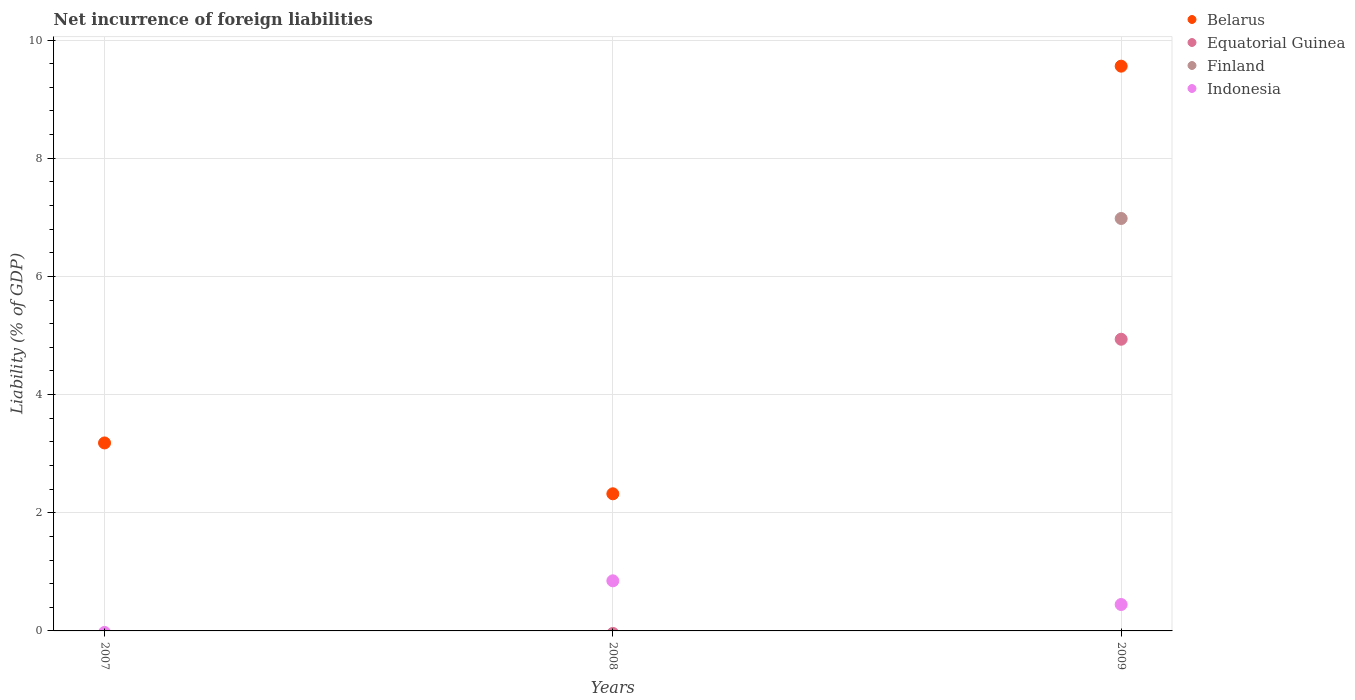How many different coloured dotlines are there?
Make the answer very short. 4. Across all years, what is the maximum net incurrence of foreign liabilities in Finland?
Provide a succinct answer. 6.98. Across all years, what is the minimum net incurrence of foreign liabilities in Finland?
Make the answer very short. 0. What is the total net incurrence of foreign liabilities in Belarus in the graph?
Your response must be concise. 15.06. What is the difference between the net incurrence of foreign liabilities in Indonesia in 2008 and that in 2009?
Your response must be concise. 0.4. What is the difference between the net incurrence of foreign liabilities in Indonesia in 2008 and the net incurrence of foreign liabilities in Equatorial Guinea in 2007?
Give a very brief answer. 0.85. What is the average net incurrence of foreign liabilities in Finland per year?
Make the answer very short. 2.33. In the year 2009, what is the difference between the net incurrence of foreign liabilities in Equatorial Guinea and net incurrence of foreign liabilities in Finland?
Ensure brevity in your answer.  -2.04. In how many years, is the net incurrence of foreign liabilities in Indonesia greater than 9.2 %?
Make the answer very short. 0. What is the ratio of the net incurrence of foreign liabilities in Indonesia in 2008 to that in 2009?
Give a very brief answer. 1.9. What is the difference between the highest and the lowest net incurrence of foreign liabilities in Belarus?
Your answer should be compact. 7.24. Is it the case that in every year, the sum of the net incurrence of foreign liabilities in Equatorial Guinea and net incurrence of foreign liabilities in Belarus  is greater than the net incurrence of foreign liabilities in Finland?
Keep it short and to the point. Yes. Is the net incurrence of foreign liabilities in Equatorial Guinea strictly greater than the net incurrence of foreign liabilities in Belarus over the years?
Make the answer very short. No. How many years are there in the graph?
Provide a succinct answer. 3. Are the values on the major ticks of Y-axis written in scientific E-notation?
Give a very brief answer. No. Does the graph contain grids?
Make the answer very short. Yes. How many legend labels are there?
Make the answer very short. 4. What is the title of the graph?
Provide a short and direct response. Net incurrence of foreign liabilities. Does "Middle East & North Africa (developing only)" appear as one of the legend labels in the graph?
Ensure brevity in your answer.  No. What is the label or title of the X-axis?
Offer a very short reply. Years. What is the label or title of the Y-axis?
Keep it short and to the point. Liability (% of GDP). What is the Liability (% of GDP) in Belarus in 2007?
Make the answer very short. 3.18. What is the Liability (% of GDP) in Equatorial Guinea in 2007?
Provide a short and direct response. 0. What is the Liability (% of GDP) of Finland in 2007?
Your response must be concise. 0. What is the Liability (% of GDP) in Belarus in 2008?
Keep it short and to the point. 2.32. What is the Liability (% of GDP) in Equatorial Guinea in 2008?
Give a very brief answer. 0. What is the Liability (% of GDP) of Finland in 2008?
Make the answer very short. 0. What is the Liability (% of GDP) of Indonesia in 2008?
Make the answer very short. 0.85. What is the Liability (% of GDP) of Belarus in 2009?
Your response must be concise. 9.56. What is the Liability (% of GDP) in Equatorial Guinea in 2009?
Offer a terse response. 4.94. What is the Liability (% of GDP) in Finland in 2009?
Give a very brief answer. 6.98. What is the Liability (% of GDP) of Indonesia in 2009?
Provide a succinct answer. 0.45. Across all years, what is the maximum Liability (% of GDP) of Belarus?
Provide a short and direct response. 9.56. Across all years, what is the maximum Liability (% of GDP) in Equatorial Guinea?
Keep it short and to the point. 4.94. Across all years, what is the maximum Liability (% of GDP) of Finland?
Your answer should be very brief. 6.98. Across all years, what is the maximum Liability (% of GDP) of Indonesia?
Your response must be concise. 0.85. Across all years, what is the minimum Liability (% of GDP) in Belarus?
Make the answer very short. 2.32. Across all years, what is the minimum Liability (% of GDP) in Indonesia?
Keep it short and to the point. 0. What is the total Liability (% of GDP) of Belarus in the graph?
Offer a very short reply. 15.06. What is the total Liability (% of GDP) in Equatorial Guinea in the graph?
Your answer should be very brief. 4.94. What is the total Liability (% of GDP) of Finland in the graph?
Your answer should be very brief. 6.98. What is the total Liability (% of GDP) of Indonesia in the graph?
Your answer should be very brief. 1.29. What is the difference between the Liability (% of GDP) in Belarus in 2007 and that in 2008?
Offer a very short reply. 0.86. What is the difference between the Liability (% of GDP) of Belarus in 2007 and that in 2009?
Your answer should be very brief. -6.38. What is the difference between the Liability (% of GDP) in Belarus in 2008 and that in 2009?
Keep it short and to the point. -7.24. What is the difference between the Liability (% of GDP) in Indonesia in 2008 and that in 2009?
Provide a succinct answer. 0.4. What is the difference between the Liability (% of GDP) of Belarus in 2007 and the Liability (% of GDP) of Indonesia in 2008?
Your answer should be compact. 2.33. What is the difference between the Liability (% of GDP) in Belarus in 2007 and the Liability (% of GDP) in Equatorial Guinea in 2009?
Provide a short and direct response. -1.76. What is the difference between the Liability (% of GDP) in Belarus in 2007 and the Liability (% of GDP) in Finland in 2009?
Provide a succinct answer. -3.8. What is the difference between the Liability (% of GDP) of Belarus in 2007 and the Liability (% of GDP) of Indonesia in 2009?
Your answer should be very brief. 2.73. What is the difference between the Liability (% of GDP) of Belarus in 2008 and the Liability (% of GDP) of Equatorial Guinea in 2009?
Offer a terse response. -2.62. What is the difference between the Liability (% of GDP) in Belarus in 2008 and the Liability (% of GDP) in Finland in 2009?
Your answer should be compact. -4.66. What is the difference between the Liability (% of GDP) in Belarus in 2008 and the Liability (% of GDP) in Indonesia in 2009?
Your answer should be compact. 1.87. What is the average Liability (% of GDP) of Belarus per year?
Your response must be concise. 5.02. What is the average Liability (% of GDP) of Equatorial Guinea per year?
Ensure brevity in your answer.  1.65. What is the average Liability (% of GDP) in Finland per year?
Provide a succinct answer. 2.33. What is the average Liability (% of GDP) in Indonesia per year?
Offer a very short reply. 0.43. In the year 2008, what is the difference between the Liability (% of GDP) in Belarus and Liability (% of GDP) in Indonesia?
Your answer should be very brief. 1.47. In the year 2009, what is the difference between the Liability (% of GDP) of Belarus and Liability (% of GDP) of Equatorial Guinea?
Offer a terse response. 4.62. In the year 2009, what is the difference between the Liability (% of GDP) of Belarus and Liability (% of GDP) of Finland?
Ensure brevity in your answer.  2.58. In the year 2009, what is the difference between the Liability (% of GDP) of Belarus and Liability (% of GDP) of Indonesia?
Make the answer very short. 9.11. In the year 2009, what is the difference between the Liability (% of GDP) in Equatorial Guinea and Liability (% of GDP) in Finland?
Provide a short and direct response. -2.04. In the year 2009, what is the difference between the Liability (% of GDP) of Equatorial Guinea and Liability (% of GDP) of Indonesia?
Your answer should be compact. 4.49. In the year 2009, what is the difference between the Liability (% of GDP) of Finland and Liability (% of GDP) of Indonesia?
Your response must be concise. 6.53. What is the ratio of the Liability (% of GDP) of Belarus in 2007 to that in 2008?
Your answer should be compact. 1.37. What is the ratio of the Liability (% of GDP) in Belarus in 2007 to that in 2009?
Provide a succinct answer. 0.33. What is the ratio of the Liability (% of GDP) in Belarus in 2008 to that in 2009?
Your answer should be compact. 0.24. What is the ratio of the Liability (% of GDP) of Indonesia in 2008 to that in 2009?
Offer a very short reply. 1.9. What is the difference between the highest and the second highest Liability (% of GDP) in Belarus?
Provide a short and direct response. 6.38. What is the difference between the highest and the lowest Liability (% of GDP) in Belarus?
Offer a terse response. 7.24. What is the difference between the highest and the lowest Liability (% of GDP) of Equatorial Guinea?
Your answer should be very brief. 4.94. What is the difference between the highest and the lowest Liability (% of GDP) of Finland?
Keep it short and to the point. 6.98. What is the difference between the highest and the lowest Liability (% of GDP) of Indonesia?
Provide a short and direct response. 0.85. 